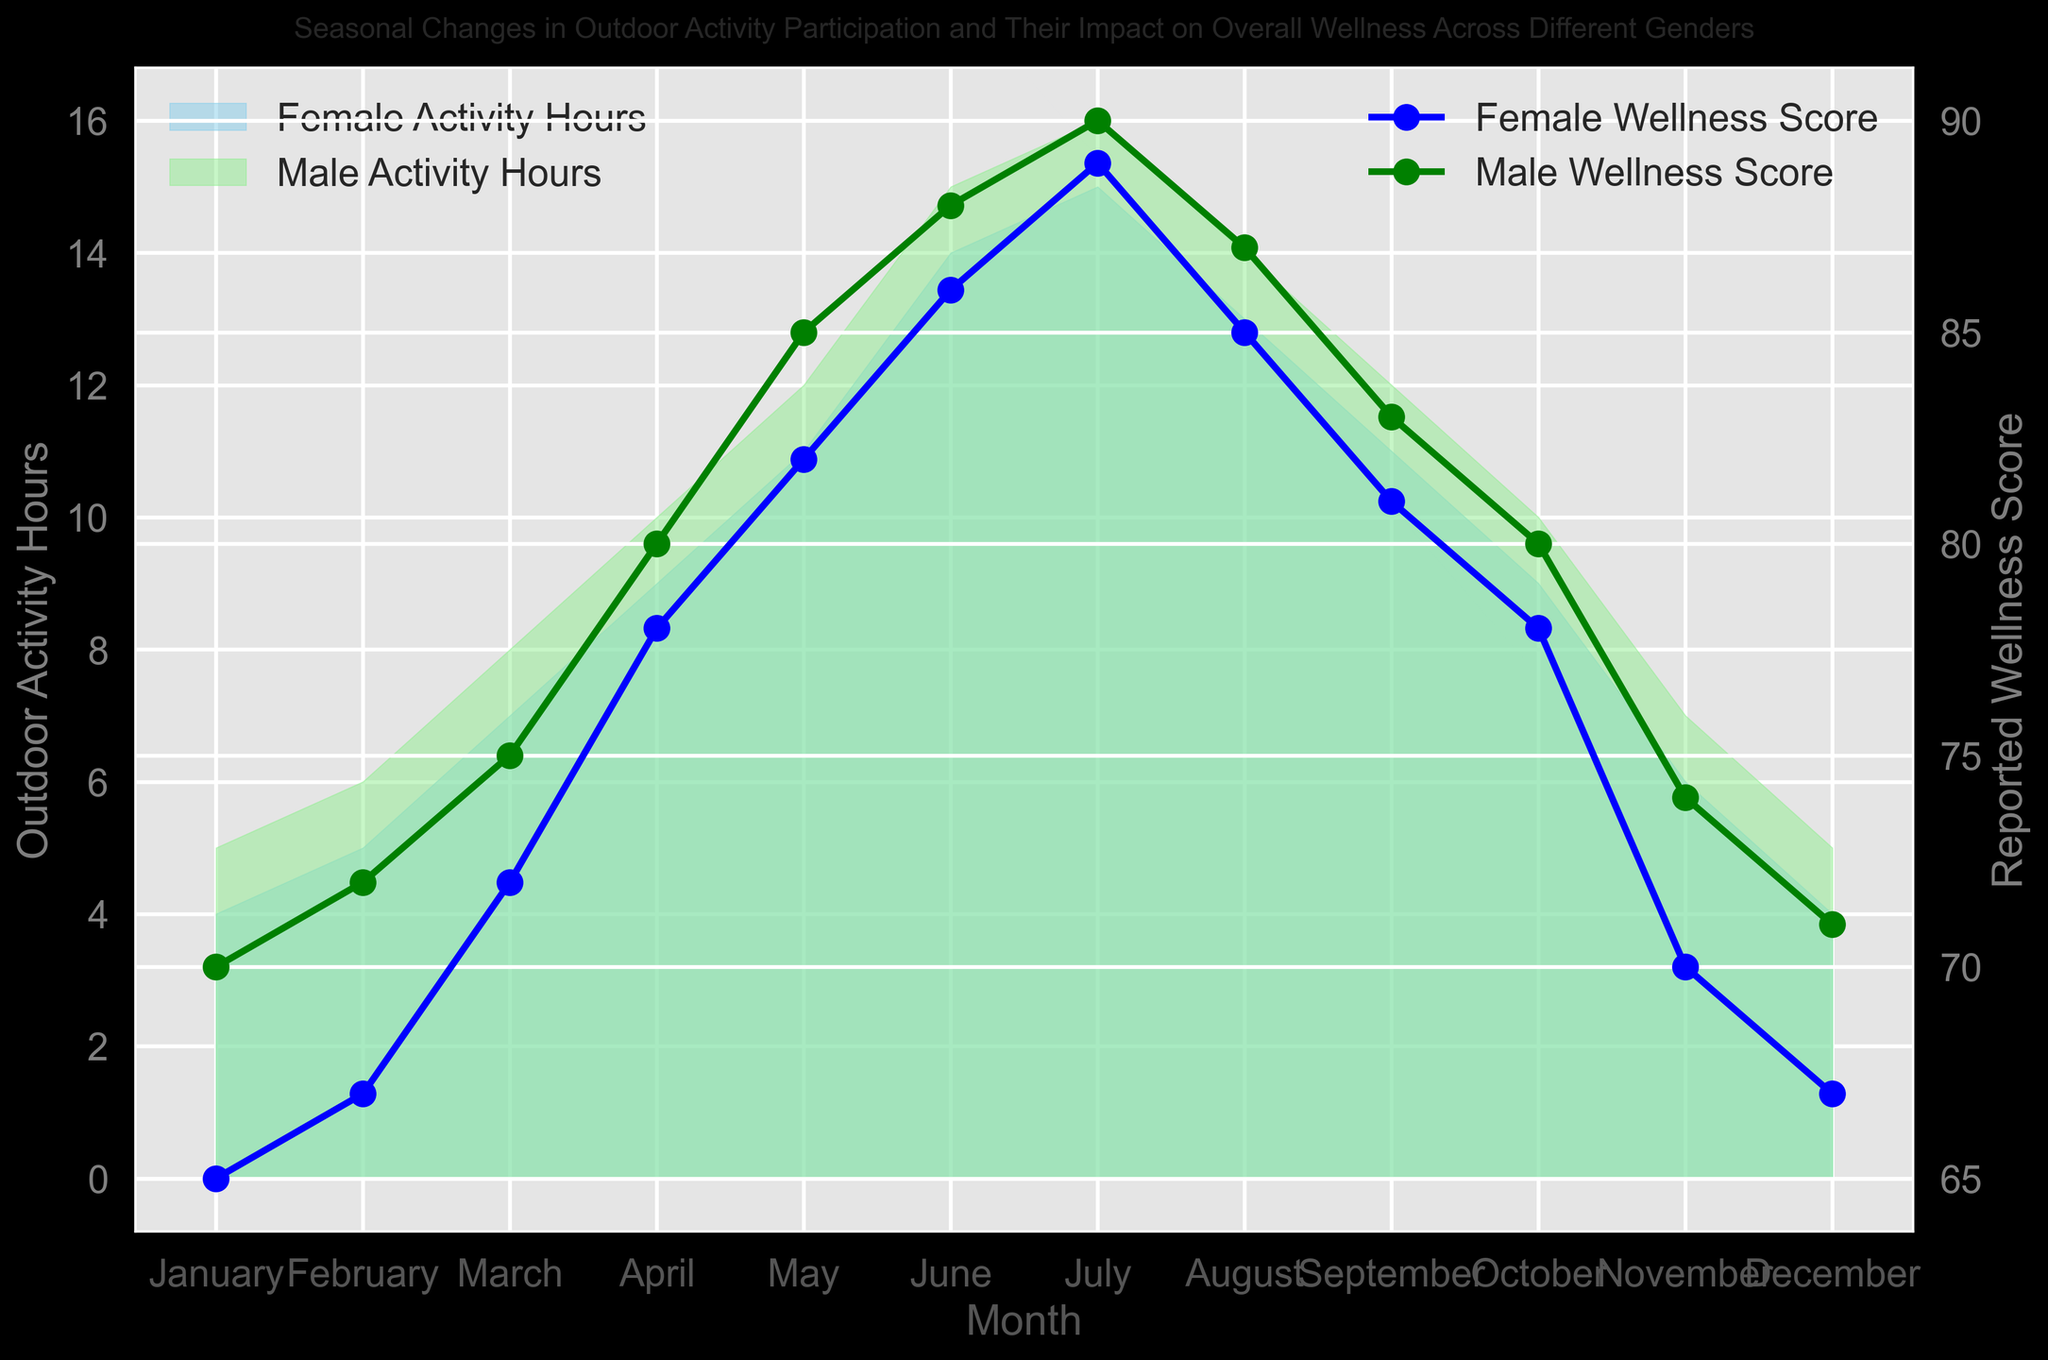What's the peak month for outdoor activity hours for both males and females? By looking at the filled areas, the peak months can be identified by the highest points on each line. For males, it's July with 16 hours, and for females, it's also July with 15 hours.
Answer: July for both How do the wellness scores for males and females change from January to July? Examine both wellness score lines from January to July. For males, the score increases from 70 to 90. For females, it increases from 65 to 89.
Answer: Both increase Which gender reports a higher wellness score in June? Compare the wellness scores for June on the vertical axis. Males report 88, while females report 86.
Answer: Males What is the average outdoor activity time for males and females across the year? Sum all the monthly outdoor activity hours for each gender and divide by 12. For males: (5+6+8+10+12+15+16+14+12+10+7+5)/12 = 10. For females: (4+5+7+9+11+14+15+13+11+9+6+4)/12 = 9.25.
Answer: 10 for males, 9.25 for females In which month do both genders have the same wellness score? Check the lines for wellness scores to see where they intersect. In February, both genders have approximately similar scores (72 for males and 67 for females, which is close but not the same). Recheck other values and find there is no exact month with identical values.
Answer: None How much higher is the male outdoor activity time compared to female time in April? Subtract the female activity hours from the male activity hours for April. Male hours are 10, and female hours are 9, so the difference is 1 hour.
Answer: 1 hour Which month shows the biggest drop in outdoor activity hours from the previous month for both genders? Find the largest decrease by comparing month-to-month changes. For males, the biggest drop is between July (16) and August (14). For females, it’s also between July (15) and August (13).
Answer: July to August What is the total increase in wellness score from January to March for females? Calculate the difference in wellness score between January and March. January is 65, and March is 72. The total increase is 72 - 65 = 7.
Answer: 7 In which month does the difference in wellness scores between males and females reach its maximum? Compare the differences between each month's male and female wellness scores. The maximum difference is in January, where males have 70 and females have 65, a difference of 5.
Answer: January Which gender shows a more consistent (less variable) outdoor activity pattern throughout the year? Look at the variation (ups and downs) in the filled areas. Females show a more consistent pattern as their activity hours vary from 4 to 15, while males vary from 5 to 16.
Answer: Females 